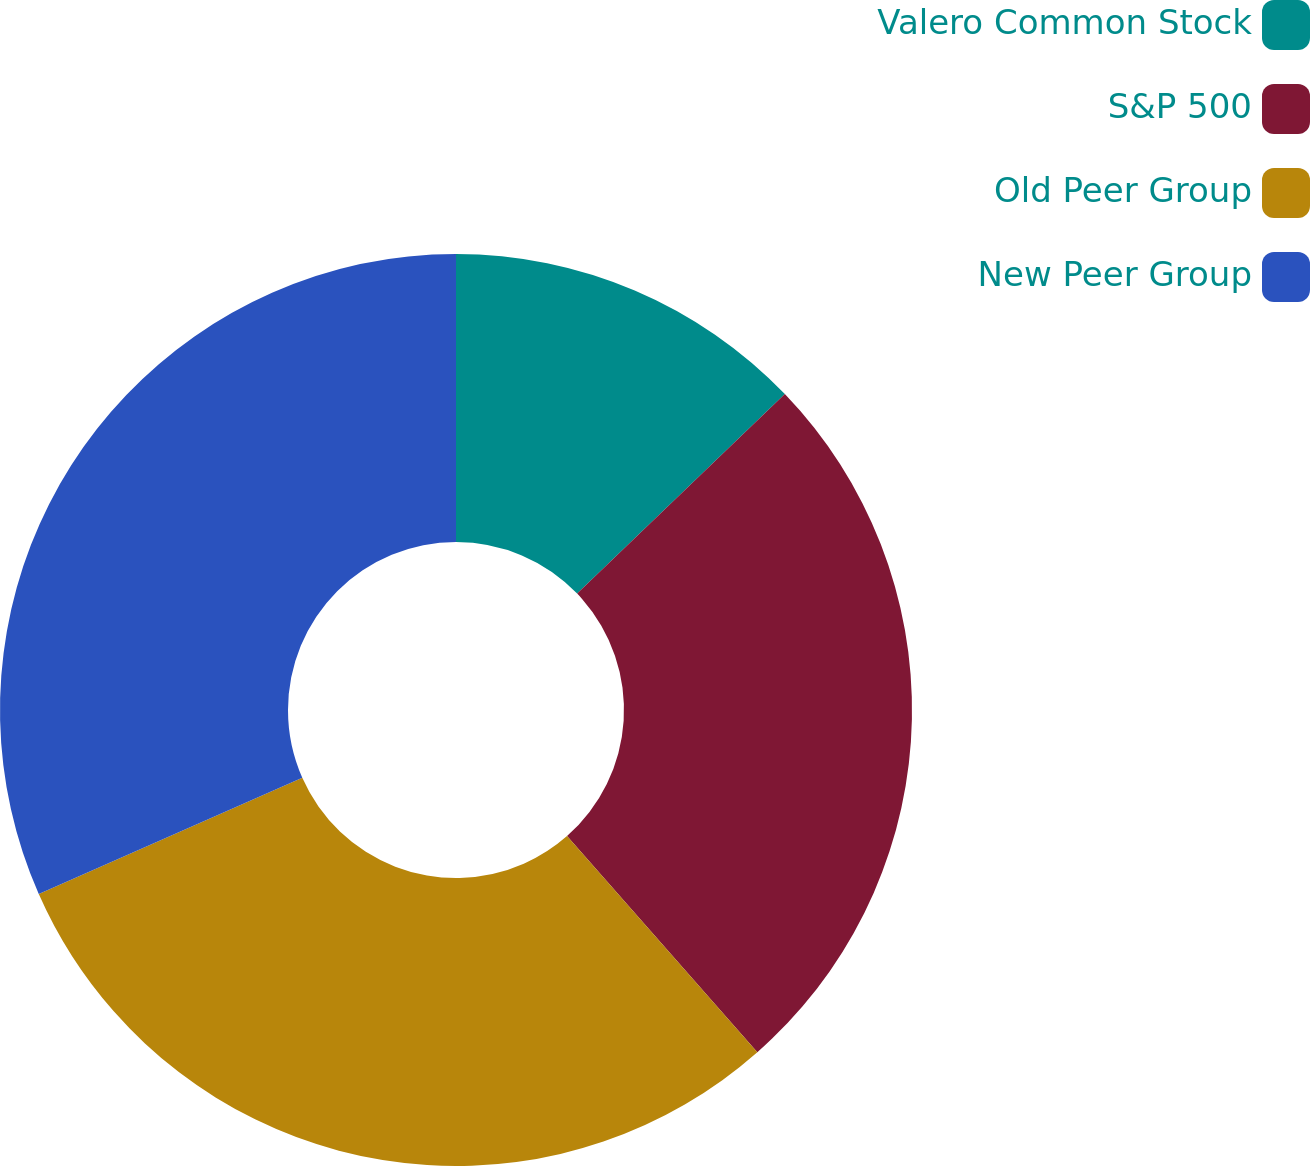Convert chart. <chart><loc_0><loc_0><loc_500><loc_500><pie_chart><fcel>Valero Common Stock<fcel>S&P 500<fcel>Old Peer Group<fcel>New Peer Group<nl><fcel>12.82%<fcel>25.69%<fcel>29.88%<fcel>31.61%<nl></chart> 